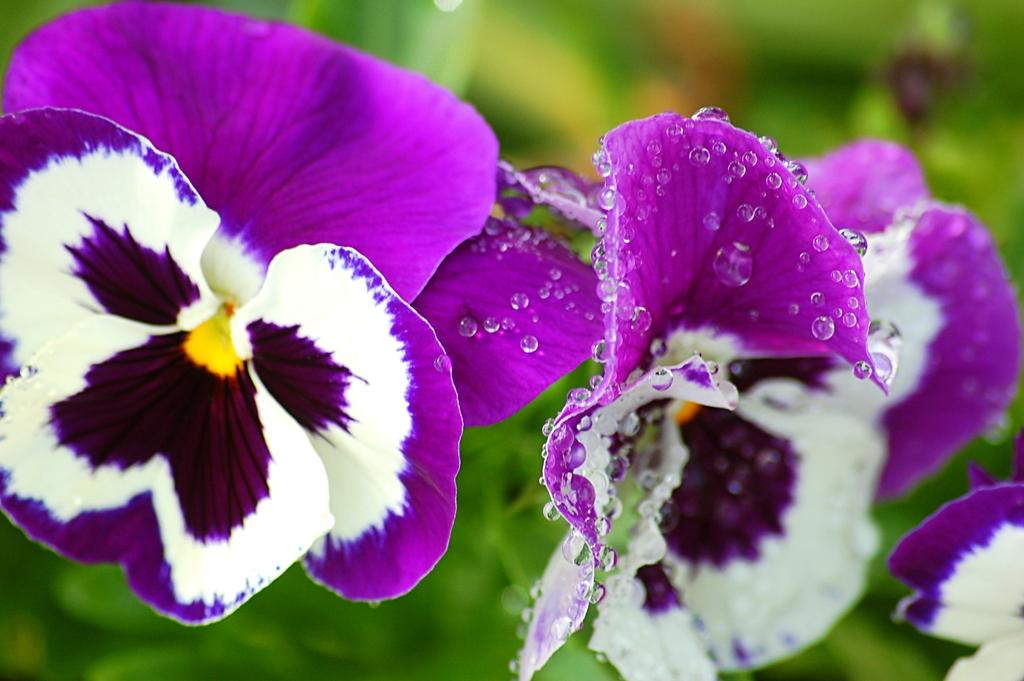What type of plants can be seen in the image? There are flowers in the image. What is the condition of the flowers? There are water droplets on the flowers. How would you describe the background of the image? The background of the image is blurry. Can you see a ticket on the flowers in the image? There is no ticket present on the flowers in the image. Is there a snake wrapped around the flowers in the image? There is no snake present in the image. 